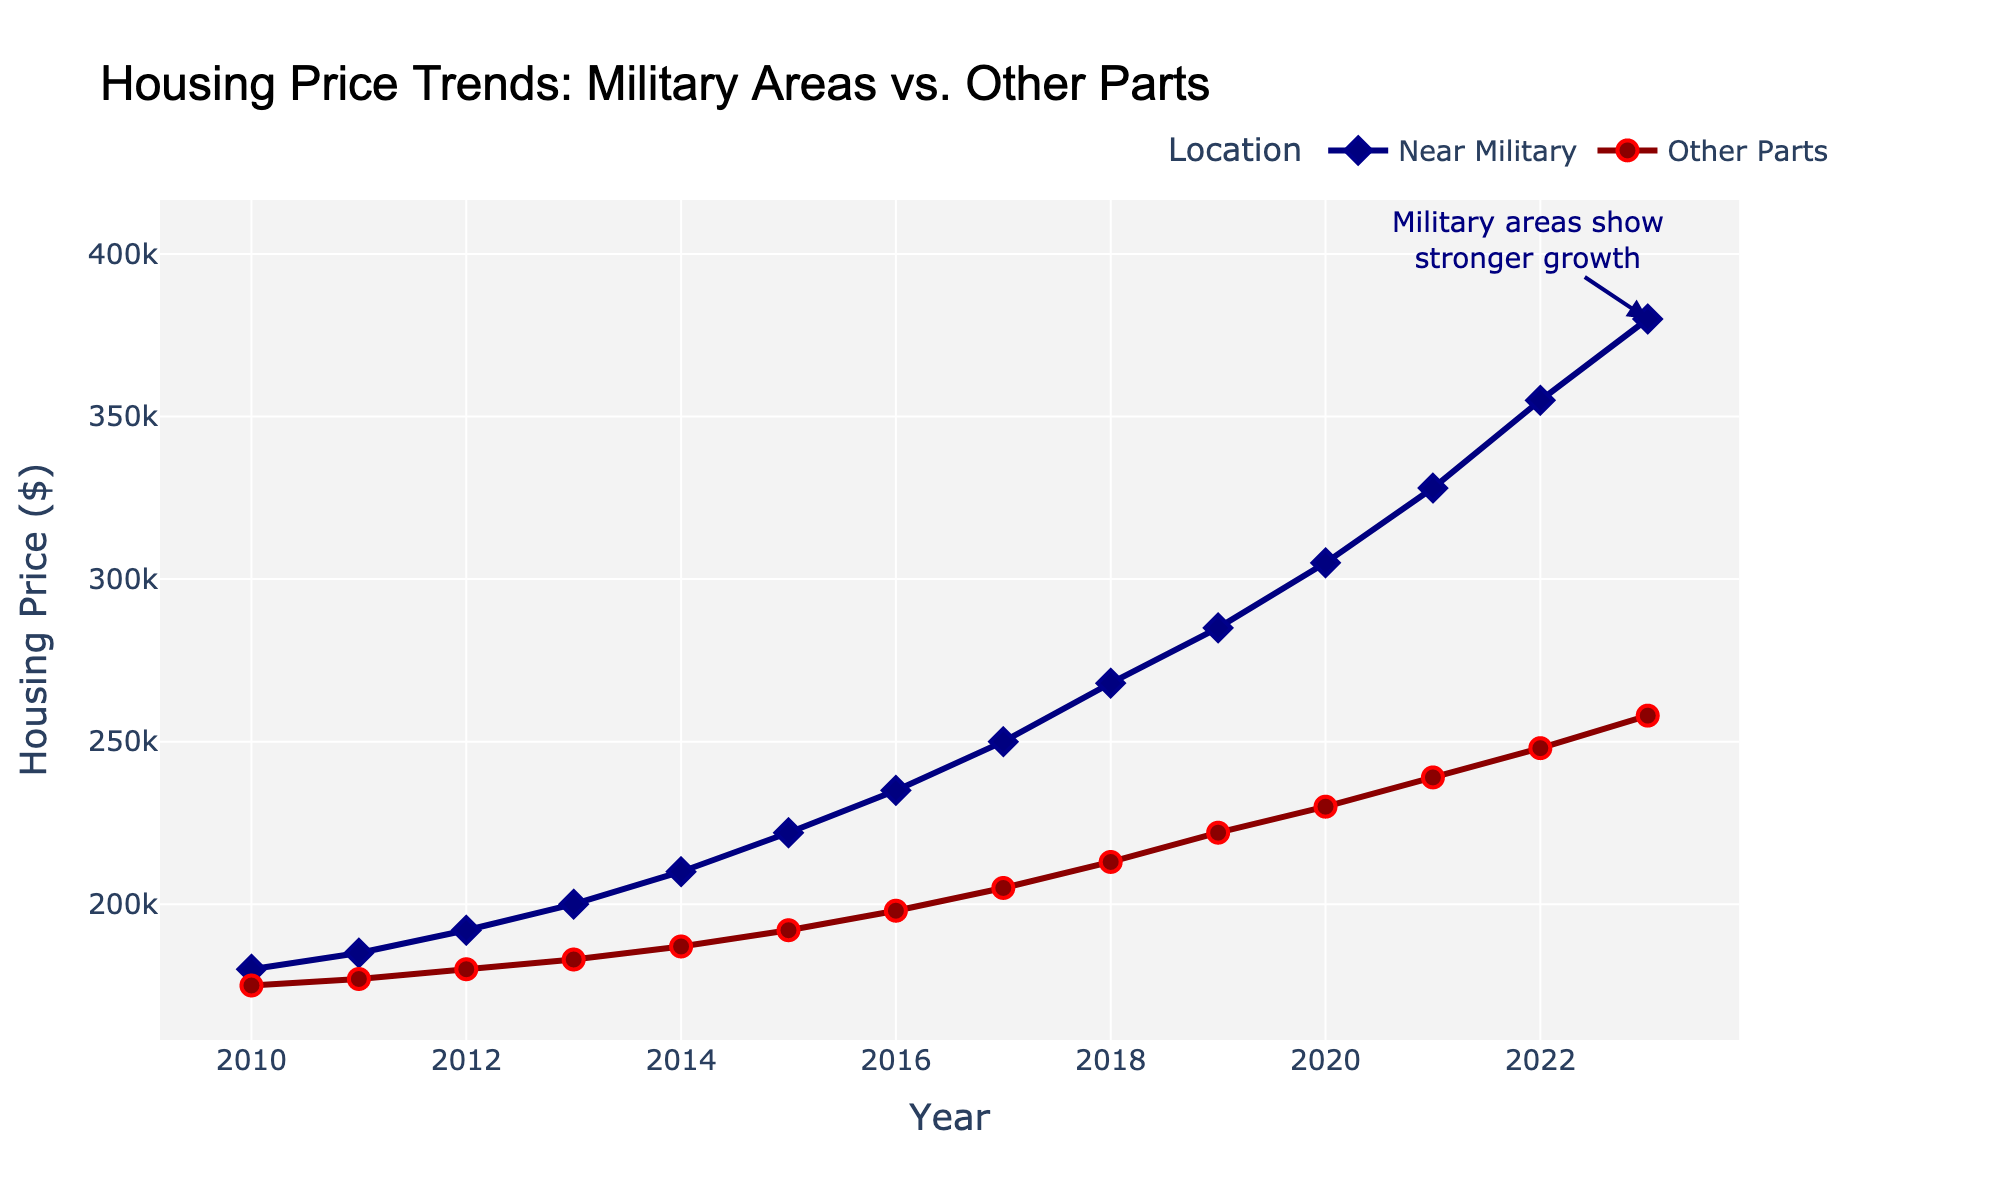what is the general trend of housing prices in military areas from 2010 to 2023? The general trend of housing prices in military areas shows a consistent increase over the years from 2010 to 2023. By examining the plot, the line representing the "Near Military" area continuously rises without any drops. This consistent upward movement indicates a steady increase in housing prices.
Answer: Increasing How much did housing prices near military installations increase from 2010 to 2023? To calculate the increase, subtract the housing price in 2010 from the price in 2023: 380,000 - 180,000 = 200,000. This means that housing prices near military installations increased by 200,000 dollars over the given time period.
Answer: 200,000 How do housing price trends in military areas compare with other parts of the town over the last decade? To compare, observe the slopes of both lines from 2013 to 2023. The line representing the "Near Military" area is steeper than the "Other Parts," indicating that the increase in housing prices near military areas is much stronger compared to other parts of the town.
Answer: Military areas have shown a stronger increase What's the difference in housing prices between areas near military installations and other parts of the town in 2023? In 2023, housing prices near military installations are 380,000 dollars whereas in other parts of the town, the prices are 258,000 dollars. The difference is 380,000 - 258,000, which equals 122,000 dollars.
Answer: 122,000 On average, how much did housing prices increase per year near military areas between 2010 and 2023? To find the average annual increase, take the total increase over the time period and divide it by the number of years. From 2010 to 2023, the total increase is 380,000 - 180,000 = 200,000 dollars. There are 13 years from 2010 to 2023. So, the average annual increase is 200,000 / 13 ≈ 15,385 dollars per year.
Answer: ≈ 15,385 How did the rate of increase in housing prices near military areas differ before 2015 and after? Compare the slopes of the line segments for the years before 2015 and from 2015 onwards. Before 2015, the increase is from 180,000 in 2010 to 222,000 in 2015 (an increase of 42,000 over 5 years). After 2015, the increase is from 222,000 in 2015 to 380,000 in 2023 (an increase of 158,000 over 8 years). The annual increase rate was 42,000 / 5 = 8,400 before 2015 and 158,000 / 8 ≈ 19,750 after 2015.
Answer: The rate increased after 2015 Which area had a higher housing price in 2013, and by how much? In 2013, housing prices near military installations were 200,000 dollars, and in other parts of the town, they were 183,000 dollars. The difference is 200,000 - 183,000 = 17,000 dollars. Thus, the military area had a higher price by 17,000 dollars.
Answer: Near military, by 17,000 What is the overall visual difference in the trend lines for the "Near Military" and "Other Parts" from 2010 to 2023? The trend line for "Near Military" is consistently steeper than the line for "Other Parts," indicating a faster increase in housing prices. Both lines are upward-trending but the steeper rise in the "Near Military" line visually signals a stronger growth rate.
Answer: "Near Military" shows a steeper, faster increase How did the housing prices in military areas change between 2019 and 2020? From the plot, the housing price in military areas increased from 285,000 dollars in 2019 to 305,000 dollars in 2020. This indicates an increase of 20,000 dollars over that year.
Answer: Increased by 20,000 